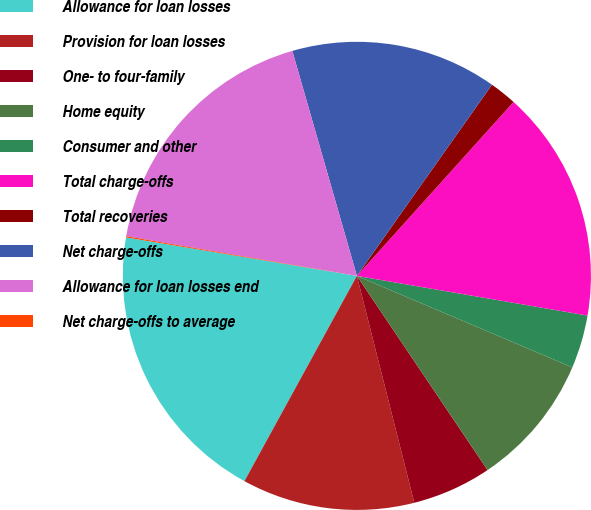<chart> <loc_0><loc_0><loc_500><loc_500><pie_chart><fcel>Allowance for loan losses<fcel>Provision for loan losses<fcel>One- to four-family<fcel>Home equity<fcel>Consumer and other<fcel>Total charge-offs<fcel>Total recoveries<fcel>Net charge-offs<fcel>Allowance for loan losses end<fcel>Net charge-offs to average<nl><fcel>19.65%<fcel>11.92%<fcel>5.48%<fcel>9.18%<fcel>3.68%<fcel>16.04%<fcel>1.88%<fcel>14.24%<fcel>17.84%<fcel>0.08%<nl></chart> 